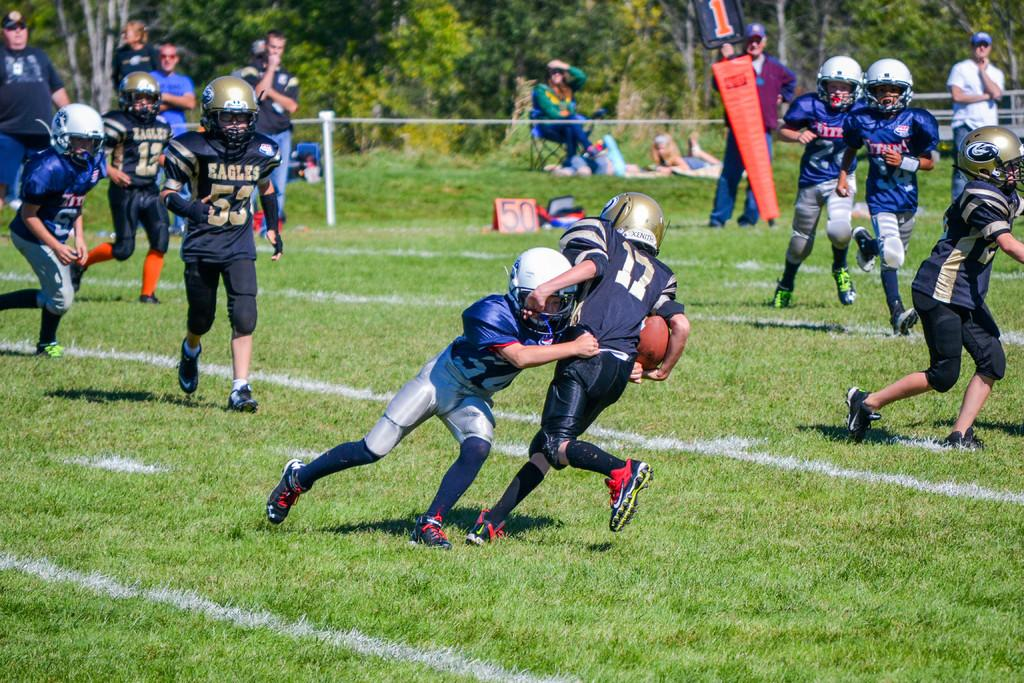What are the people in the image doing? The people in the image are playing a game with a ball. What can be seen in the background of the image? There is grass, iron rods, a person sitting on a chair, and plants in the background of the image. What time is displayed on the clock in the image? There is no clock present in the image. How much waste is visible in the image? There is no waste visible in the image. 